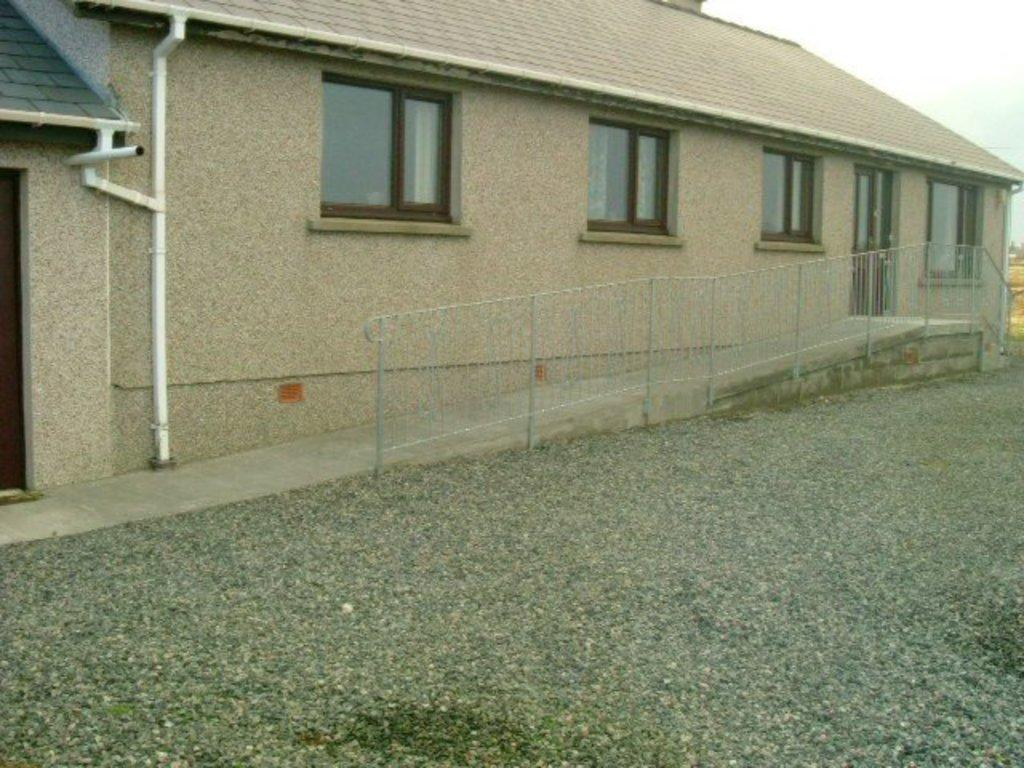What is the main structure in the center of the image? There is a house in the center of the image. What type of architectural feature can be seen in the image? There are railings in the image. What other objects are present in the image? There are pipes in the image. What is visible at the bottom of the image? There is a walkway at the bottom of the image. What is visible at the top of the image? The sky is visible at the top of the image. What type of plant can be seen growing through the pipes in the image? There is no plant visible in the image, and no plants are growing through the pipes. What type of office can be seen in the image? There is no office present in the image; it features a house, railings, pipes, a walkway, and the sky. 